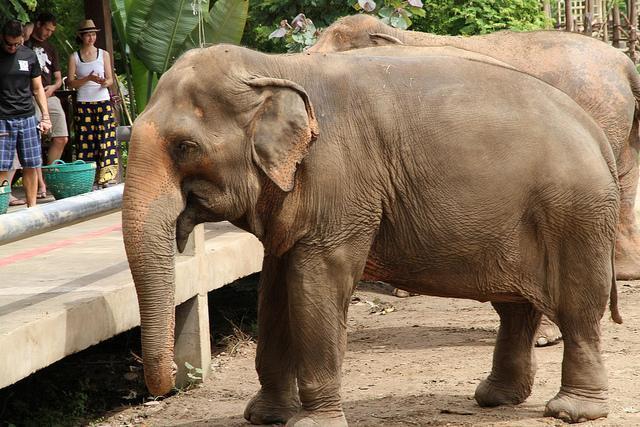What is this place?
Pick the right solution, then justify: 'Answer: answer
Rationale: rationale.'
Options: Resort, circus, school, zoo. Answer: zoo.
Rationale: The animals are clearly in captivity and there are spectators standing along the sidelines to view them. 